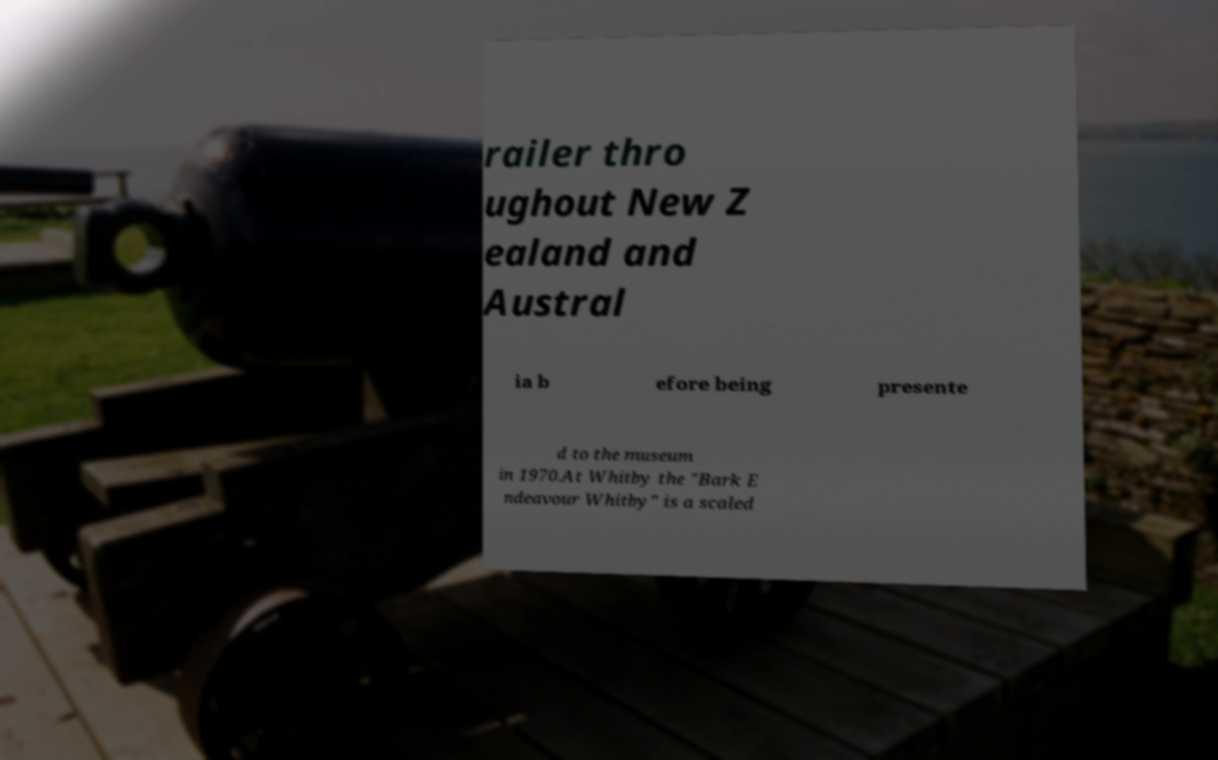There's text embedded in this image that I need extracted. Can you transcribe it verbatim? railer thro ughout New Z ealand and Austral ia b efore being presente d to the museum in 1970.At Whitby the "Bark E ndeavour Whitby" is a scaled 